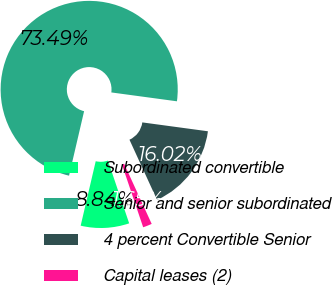<chart> <loc_0><loc_0><loc_500><loc_500><pie_chart><fcel>Subordinated convertible<fcel>Senior and senior subordinated<fcel>4 percent Convertible Senior<fcel>Capital leases (2)<nl><fcel>8.84%<fcel>73.49%<fcel>16.02%<fcel>1.65%<nl></chart> 